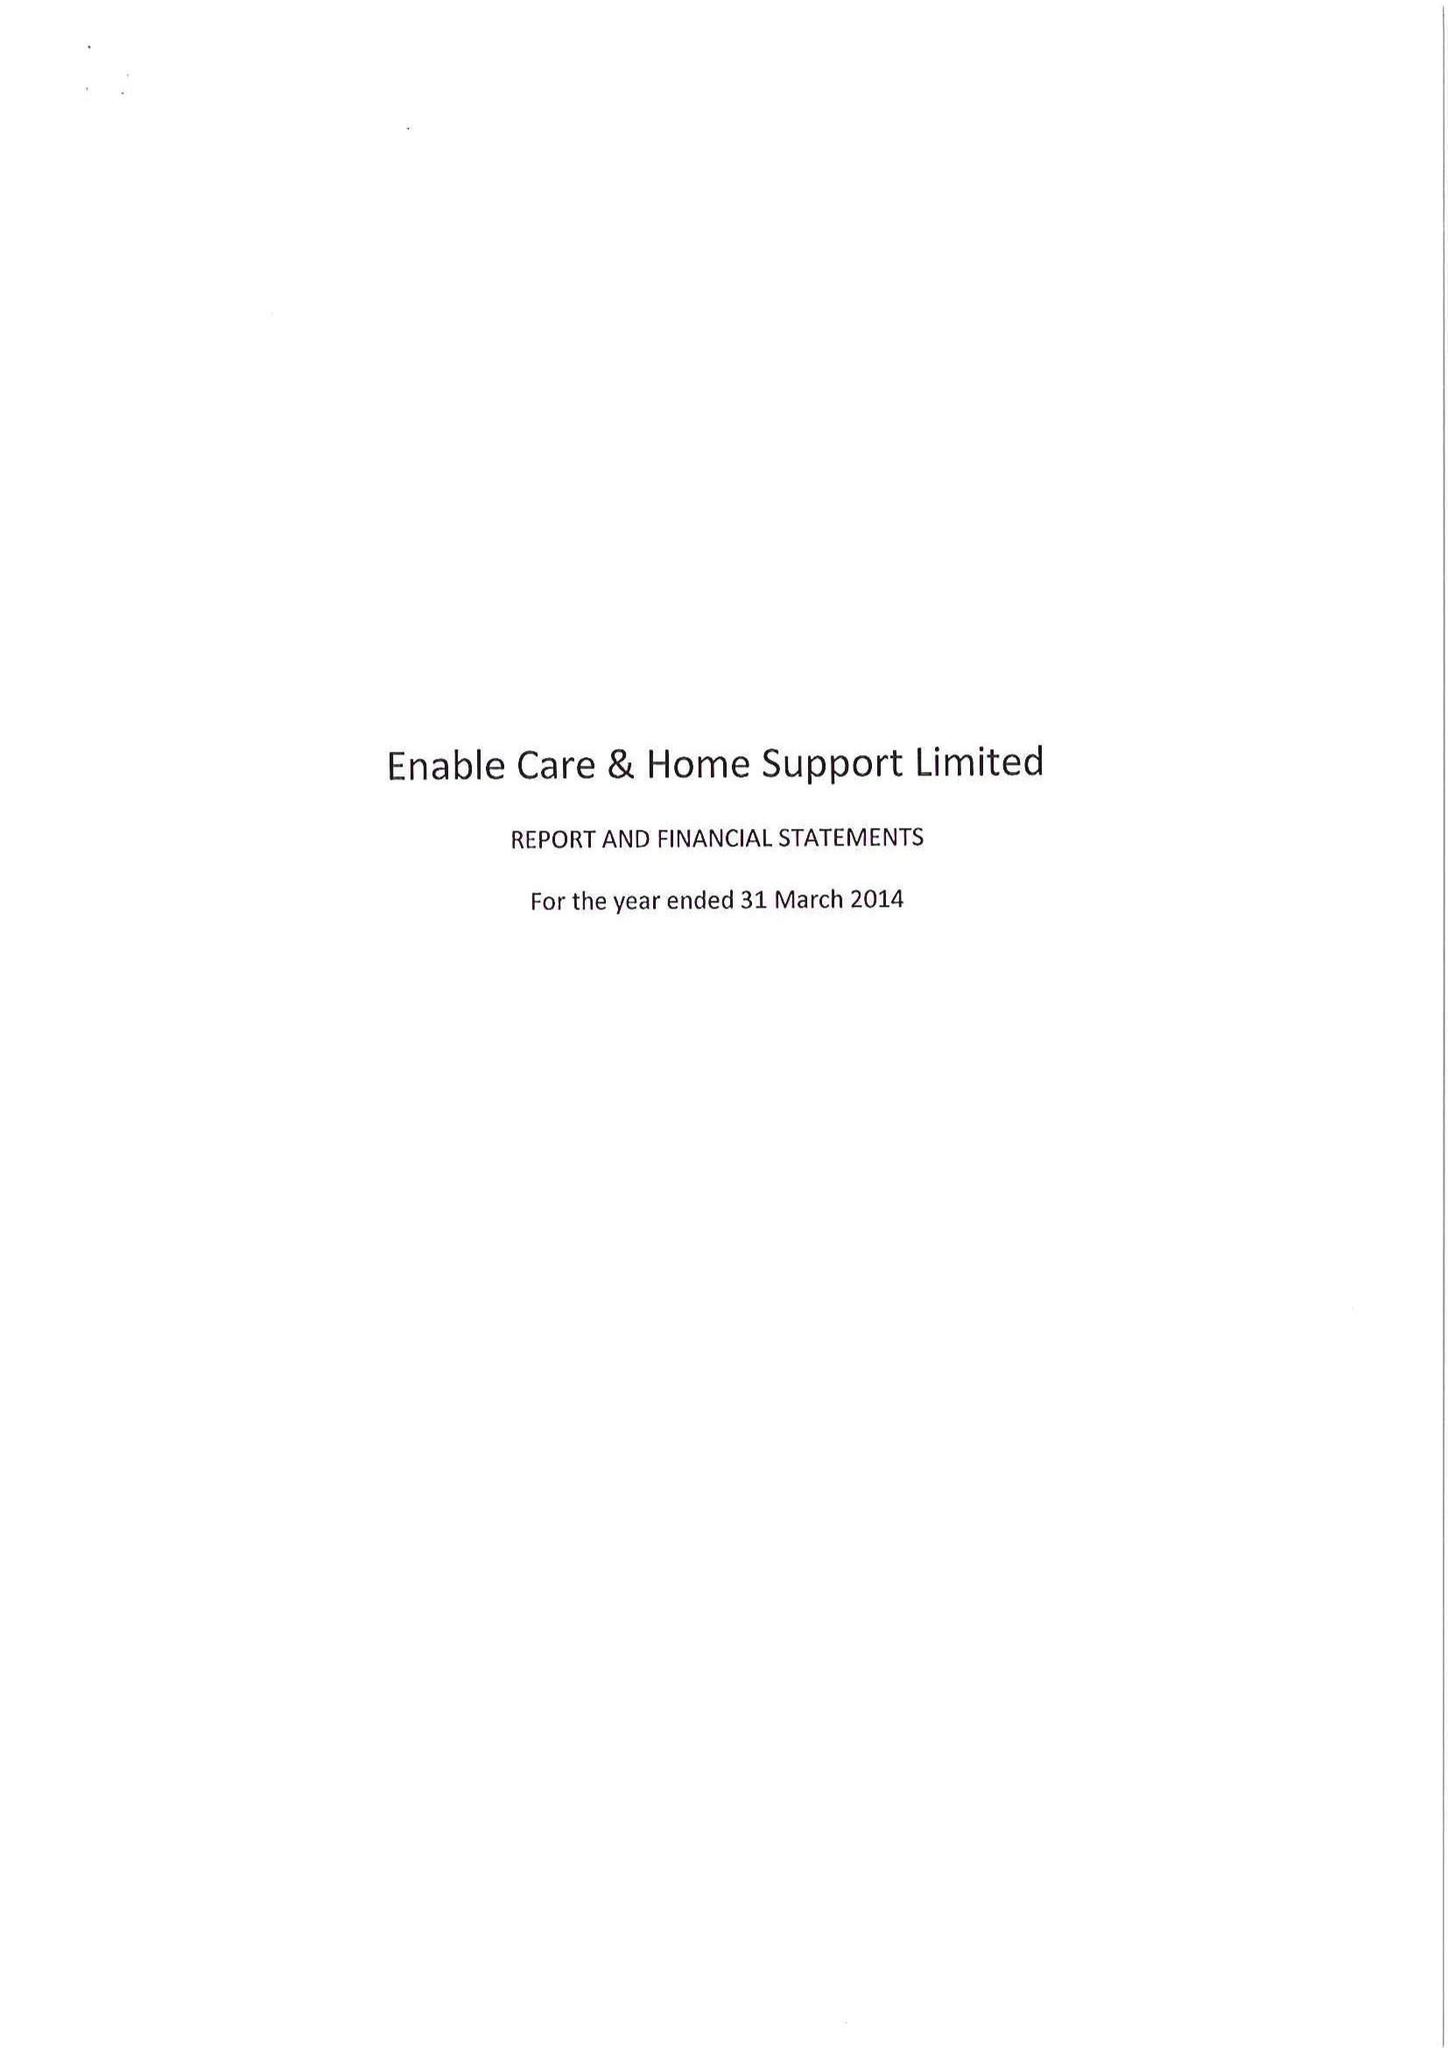What is the value for the report_date?
Answer the question using a single word or phrase. 2014-03-31 